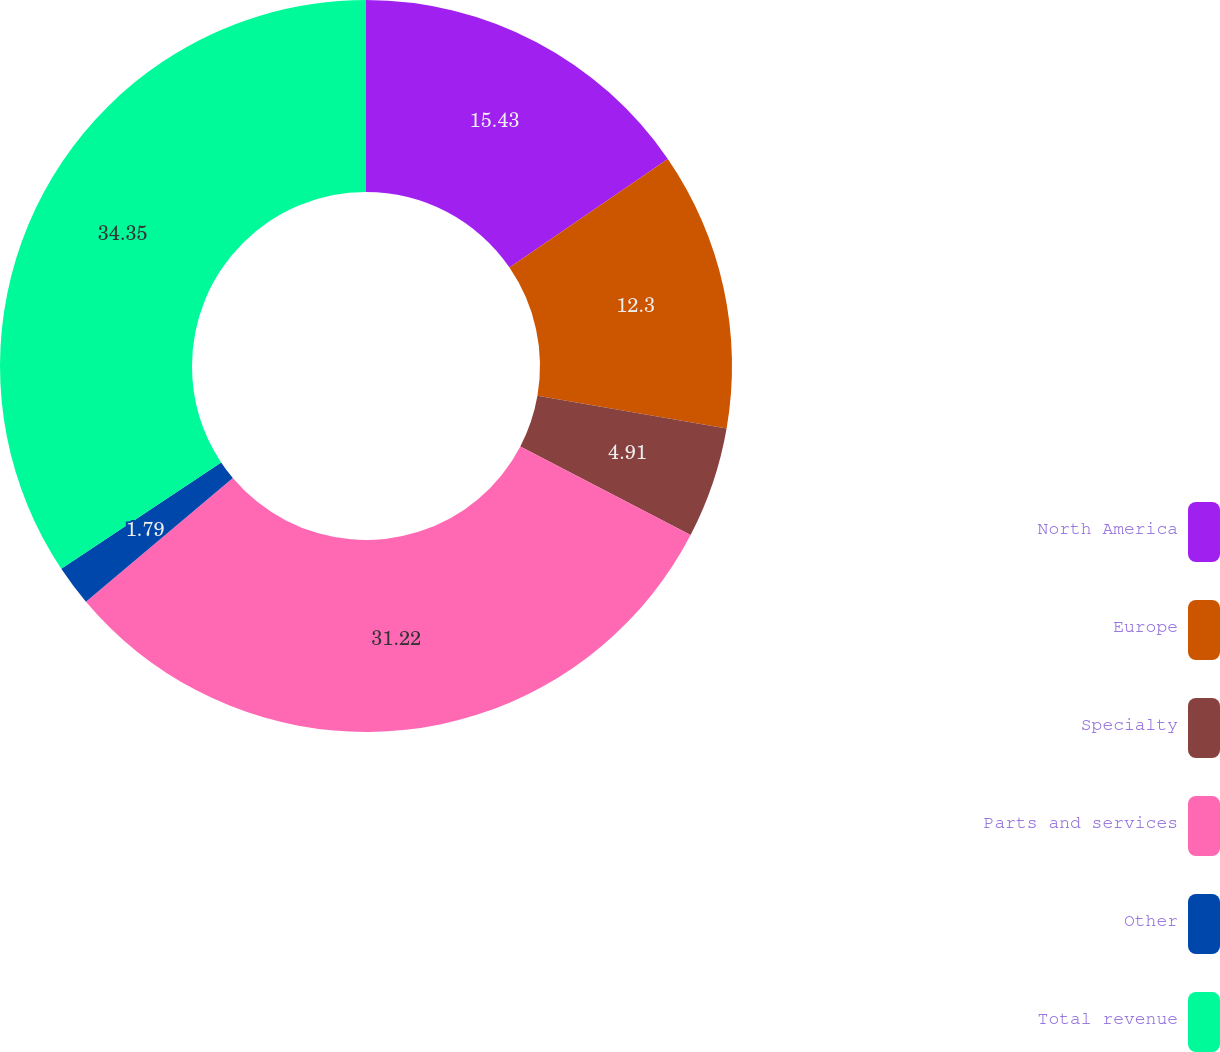Convert chart. <chart><loc_0><loc_0><loc_500><loc_500><pie_chart><fcel>North America<fcel>Europe<fcel>Specialty<fcel>Parts and services<fcel>Other<fcel>Total revenue<nl><fcel>15.43%<fcel>12.3%<fcel>4.91%<fcel>31.22%<fcel>1.79%<fcel>34.34%<nl></chart> 